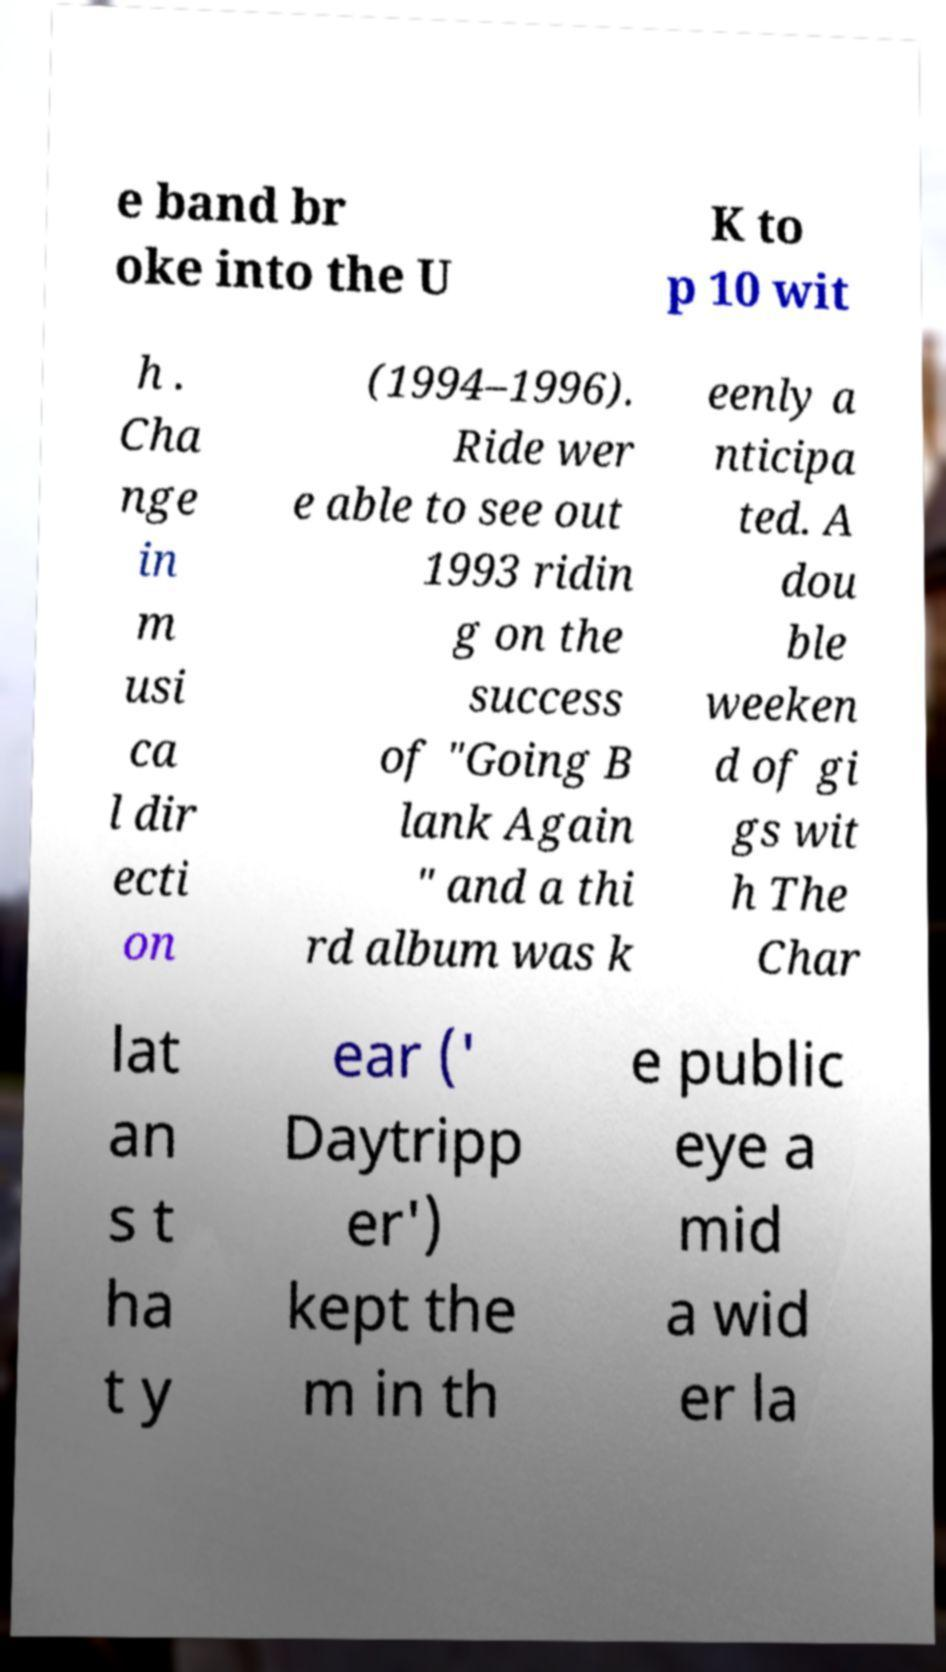Could you extract and type out the text from this image? e band br oke into the U K to p 10 wit h . Cha nge in m usi ca l dir ecti on (1994–1996). Ride wer e able to see out 1993 ridin g on the success of "Going B lank Again " and a thi rd album was k eenly a nticipa ted. A dou ble weeken d of gi gs wit h The Char lat an s t ha t y ear (' Daytripp er') kept the m in th e public eye a mid a wid er la 